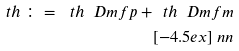Convert formula to latex. <formula><loc_0><loc_0><loc_500><loc_500>\ t h \, \colon = \, \ t h \ D m f p + \ t h \ D m f m \\ [ - 4 . 5 e x ] \ n n</formula> 